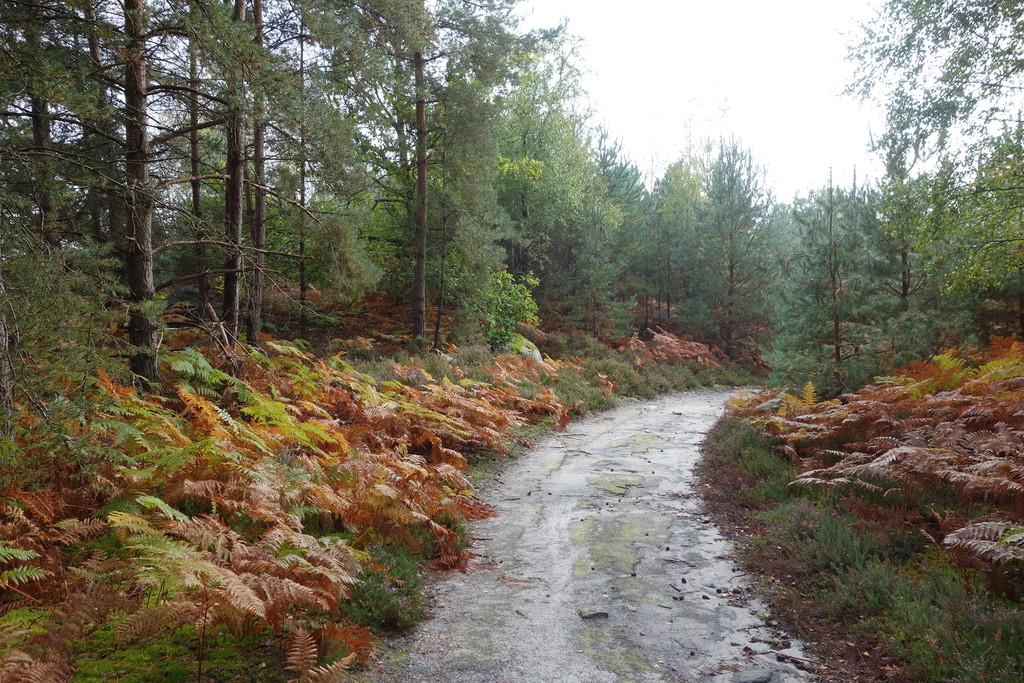What is the main subject of the image? The main subject of the image is an empty road. What type of vegetation can be seen in the image? There are plants, trees, and grass visible in the image. How many cherries are hanging from the trees in the image? There are no cherries visible in the image; only plants, trees, and grass can be seen. 